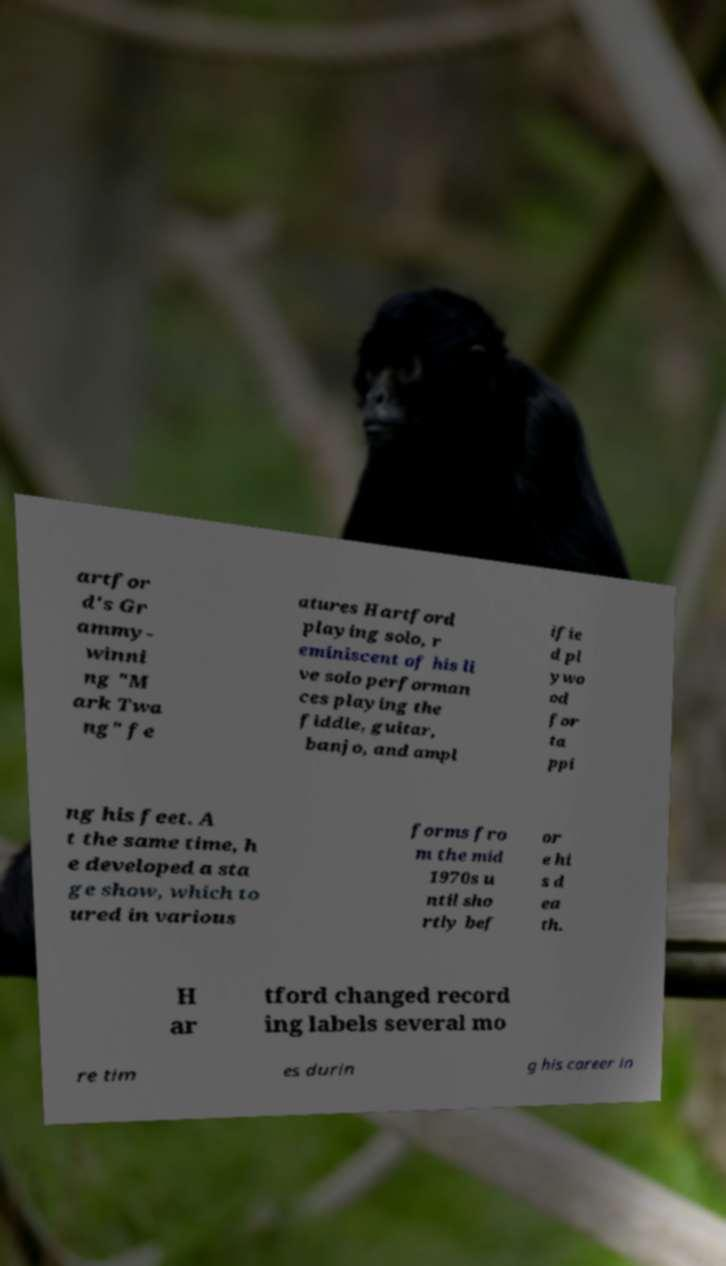Could you assist in decoding the text presented in this image and type it out clearly? artfor d's Gr ammy- winni ng "M ark Twa ng" fe atures Hartford playing solo, r eminiscent of his li ve solo performan ces playing the fiddle, guitar, banjo, and ampl ifie d pl ywo od for ta ppi ng his feet. A t the same time, h e developed a sta ge show, which to ured in various forms fro m the mid 1970s u ntil sho rtly bef or e hi s d ea th. H ar tford changed record ing labels several mo re tim es durin g his career in 